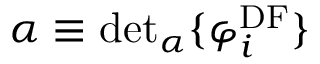<formula> <loc_0><loc_0><loc_500><loc_500>\alpha \equiv d e t _ { \alpha } \{ \varphi _ { i } ^ { D F } \}</formula> 